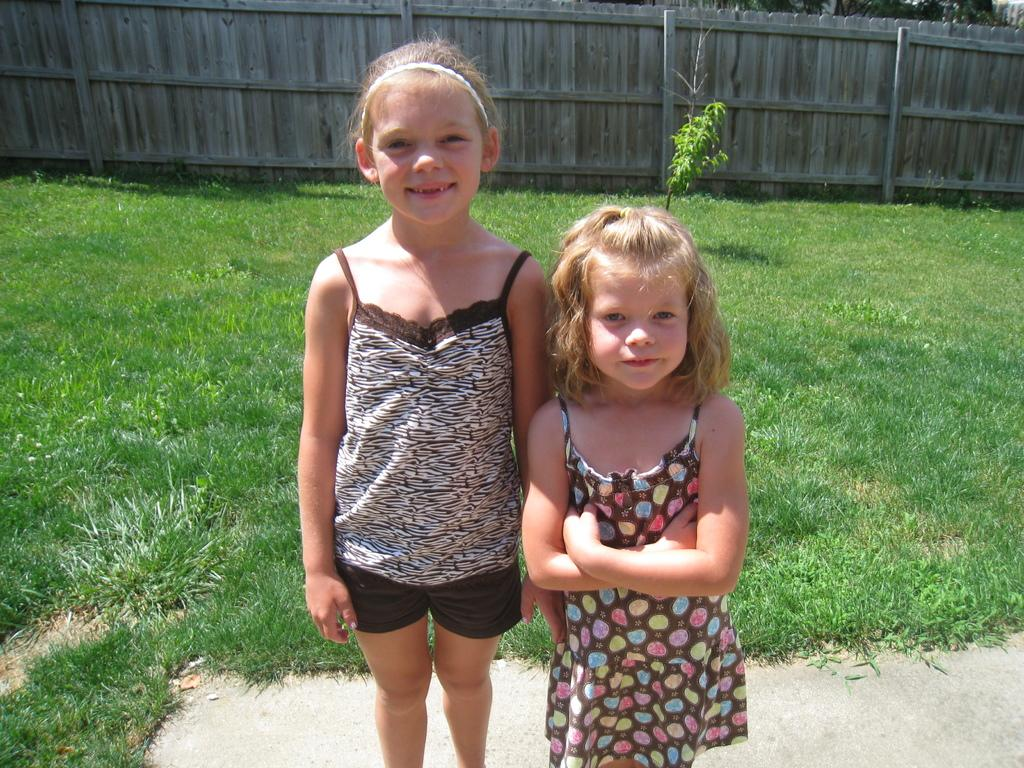How many girls are present in the image? There are two girls standing in the image. What can be seen in the background of the image? There is grassy land, a plant, and a wooden boundary in the background of the image. What type of shoe is the jellyfish wearing in the image? There is no jellyfish or shoe present in the image. 